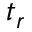Convert formula to latex. <formula><loc_0><loc_0><loc_500><loc_500>t _ { r }</formula> 